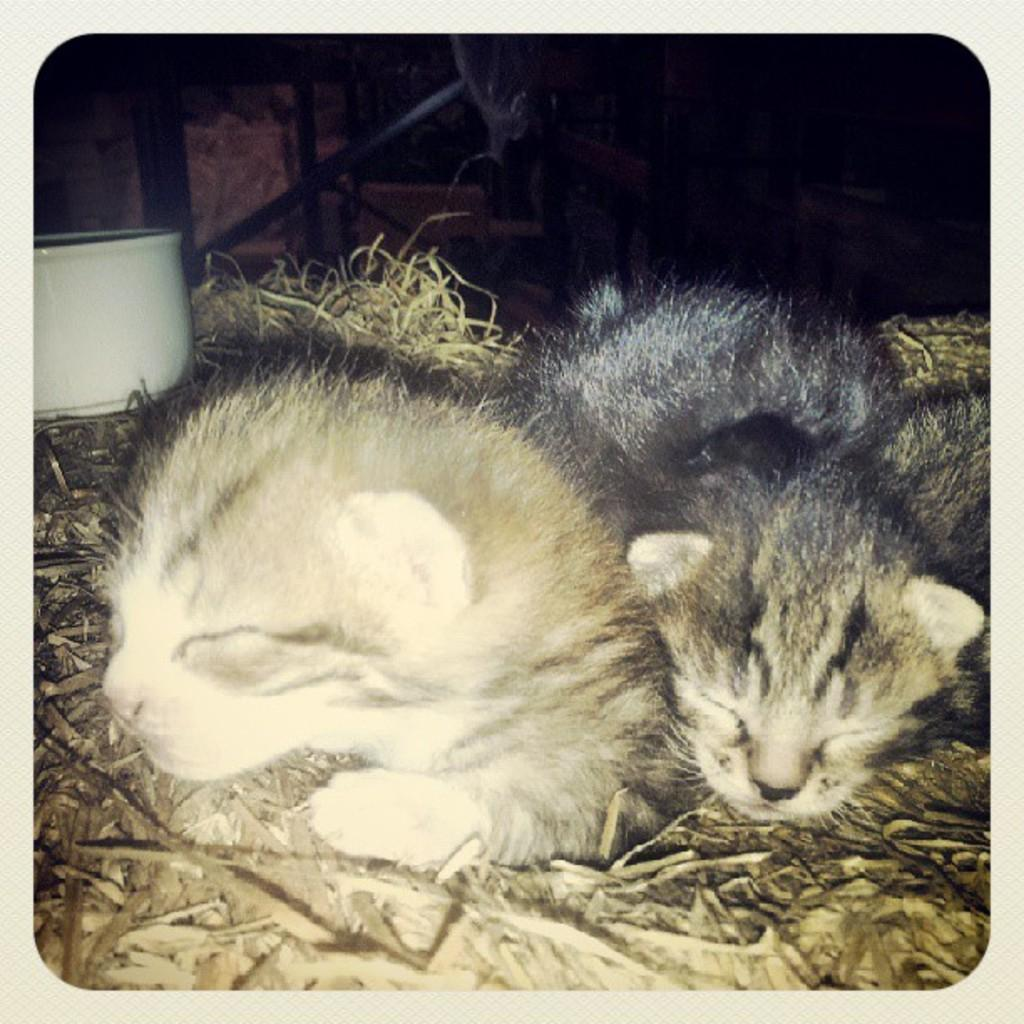How many kittens are in the image? There are two kittens in the image. What are the kittens doing in the image? The kittens are lying on the grass. What color is the object in the background on the left side? The object in the background on the left side is white. What else can be seen in the background of the image? There are other things visible in the background, but their specific details are not mentioned in the provided facts. What type of cabbage is growing near the kittens in the image? There is no cabbage present in the image; the kittens are lying on the grass. Can you tell me how many lakes are visible in the image? There is no lake visible in the image; the focus is on the kittens and the white object in the background. 